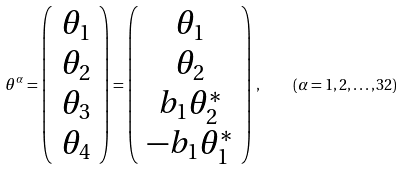<formula> <loc_0><loc_0><loc_500><loc_500>\theta ^ { \alpha } = \left ( \begin{array} { c } \theta _ { 1 } \\ \theta _ { 2 } \\ \theta _ { 3 } \\ \theta _ { 4 } \end{array} \right ) = \left ( \begin{array} { c } \theta _ { 1 } \\ \theta _ { 2 } \\ b _ { 1 } \theta _ { 2 } ^ { * } \\ - b _ { 1 } \theta _ { 1 } ^ { * } \end{array} \right ) \, , \quad ( \alpha = 1 , 2 , \dots , 3 2 )</formula> 